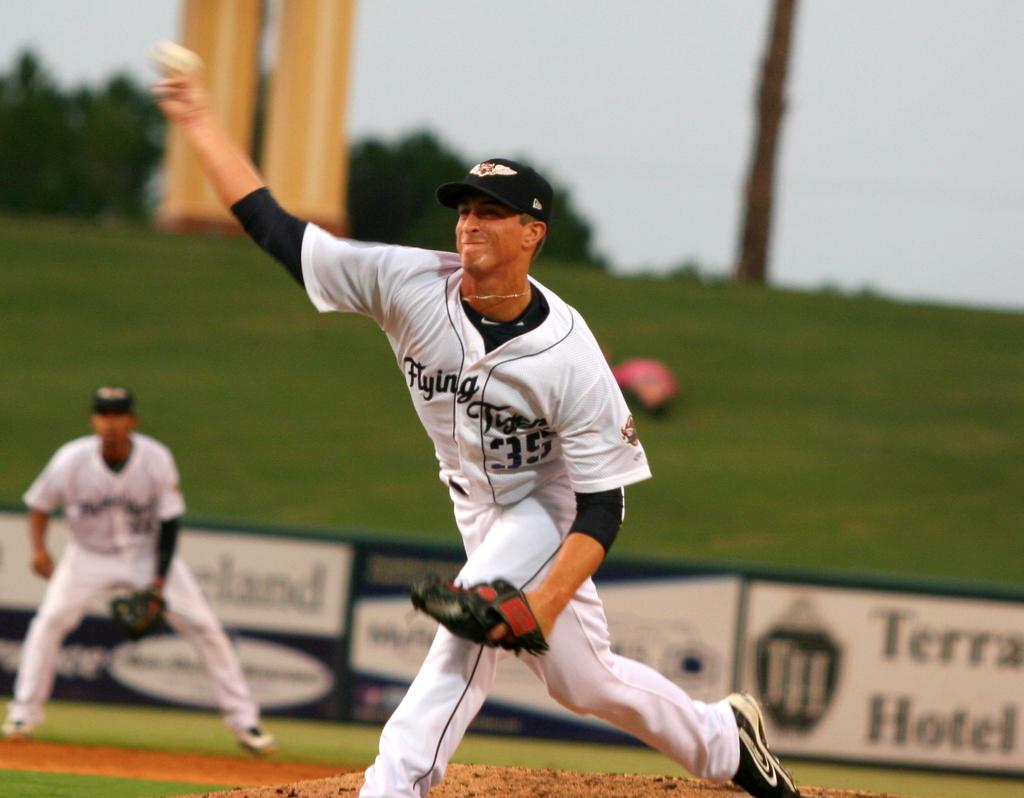What is the name of the hotel being advertised?
Provide a succinct answer. Terra hotel. What is the number of the pitcher's jersey?
Provide a short and direct response. 35. 